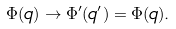<formula> <loc_0><loc_0><loc_500><loc_500>\Phi ( q ) \rightarrow \Phi ^ { \prime } ( q ^ { \prime } ) = \Phi ( q ) .</formula> 